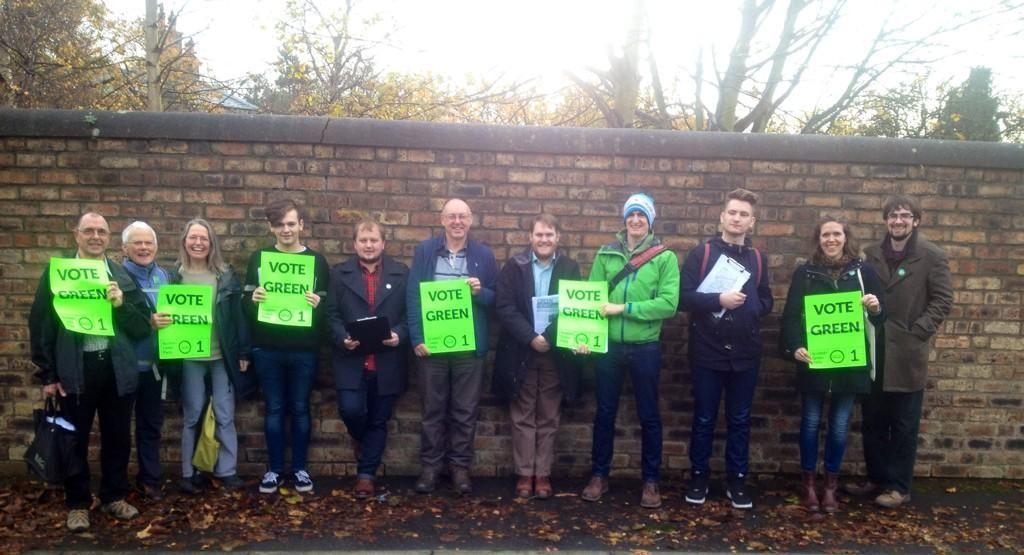Can you describe this image briefly? In this image we can see few people standing on the ground and holding posters with text and few objects, there is a wall, few trees and the sky in the background. 